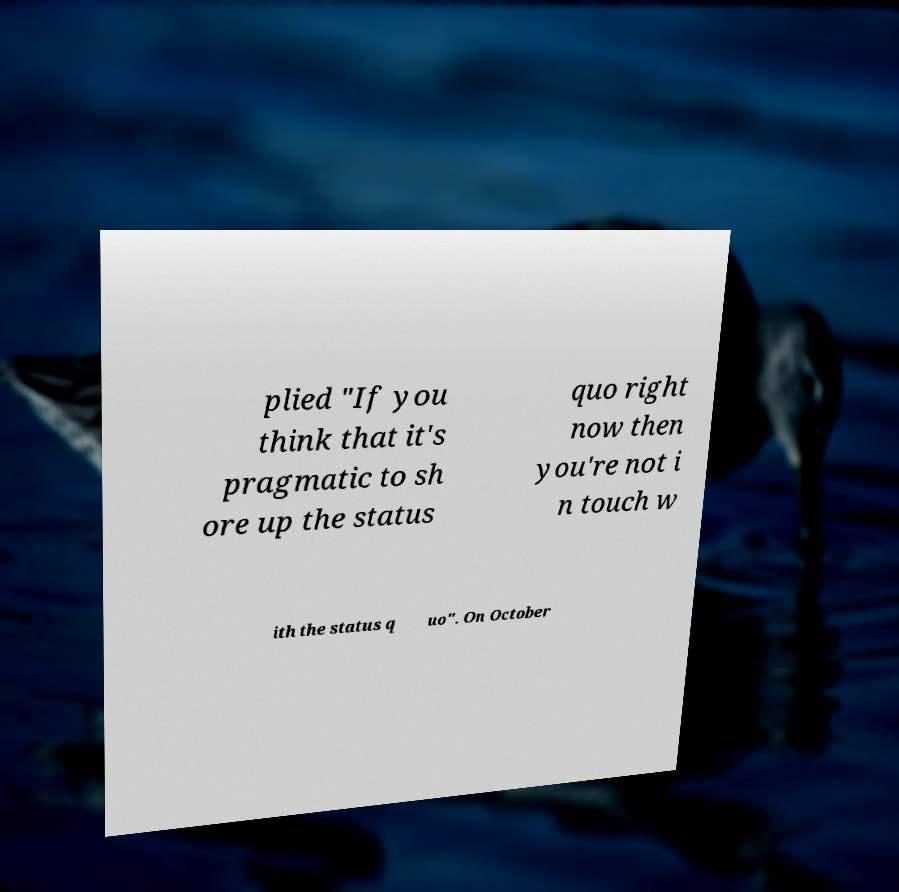For documentation purposes, I need the text within this image transcribed. Could you provide that? plied "If you think that it's pragmatic to sh ore up the status quo right now then you're not i n touch w ith the status q uo". On October 